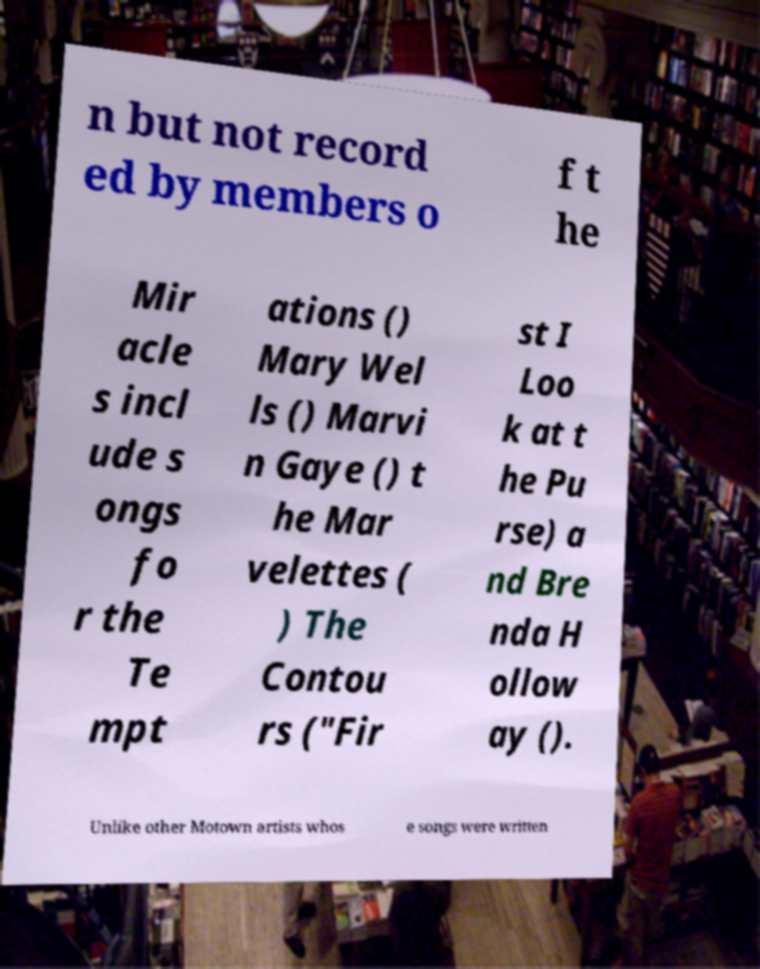I need the written content from this picture converted into text. Can you do that? n but not record ed by members o f t he Mir acle s incl ude s ongs fo r the Te mpt ations () Mary Wel ls () Marvi n Gaye () t he Mar velettes ( ) The Contou rs ("Fir st I Loo k at t he Pu rse) a nd Bre nda H ollow ay (). Unlike other Motown artists whos e songs were written 